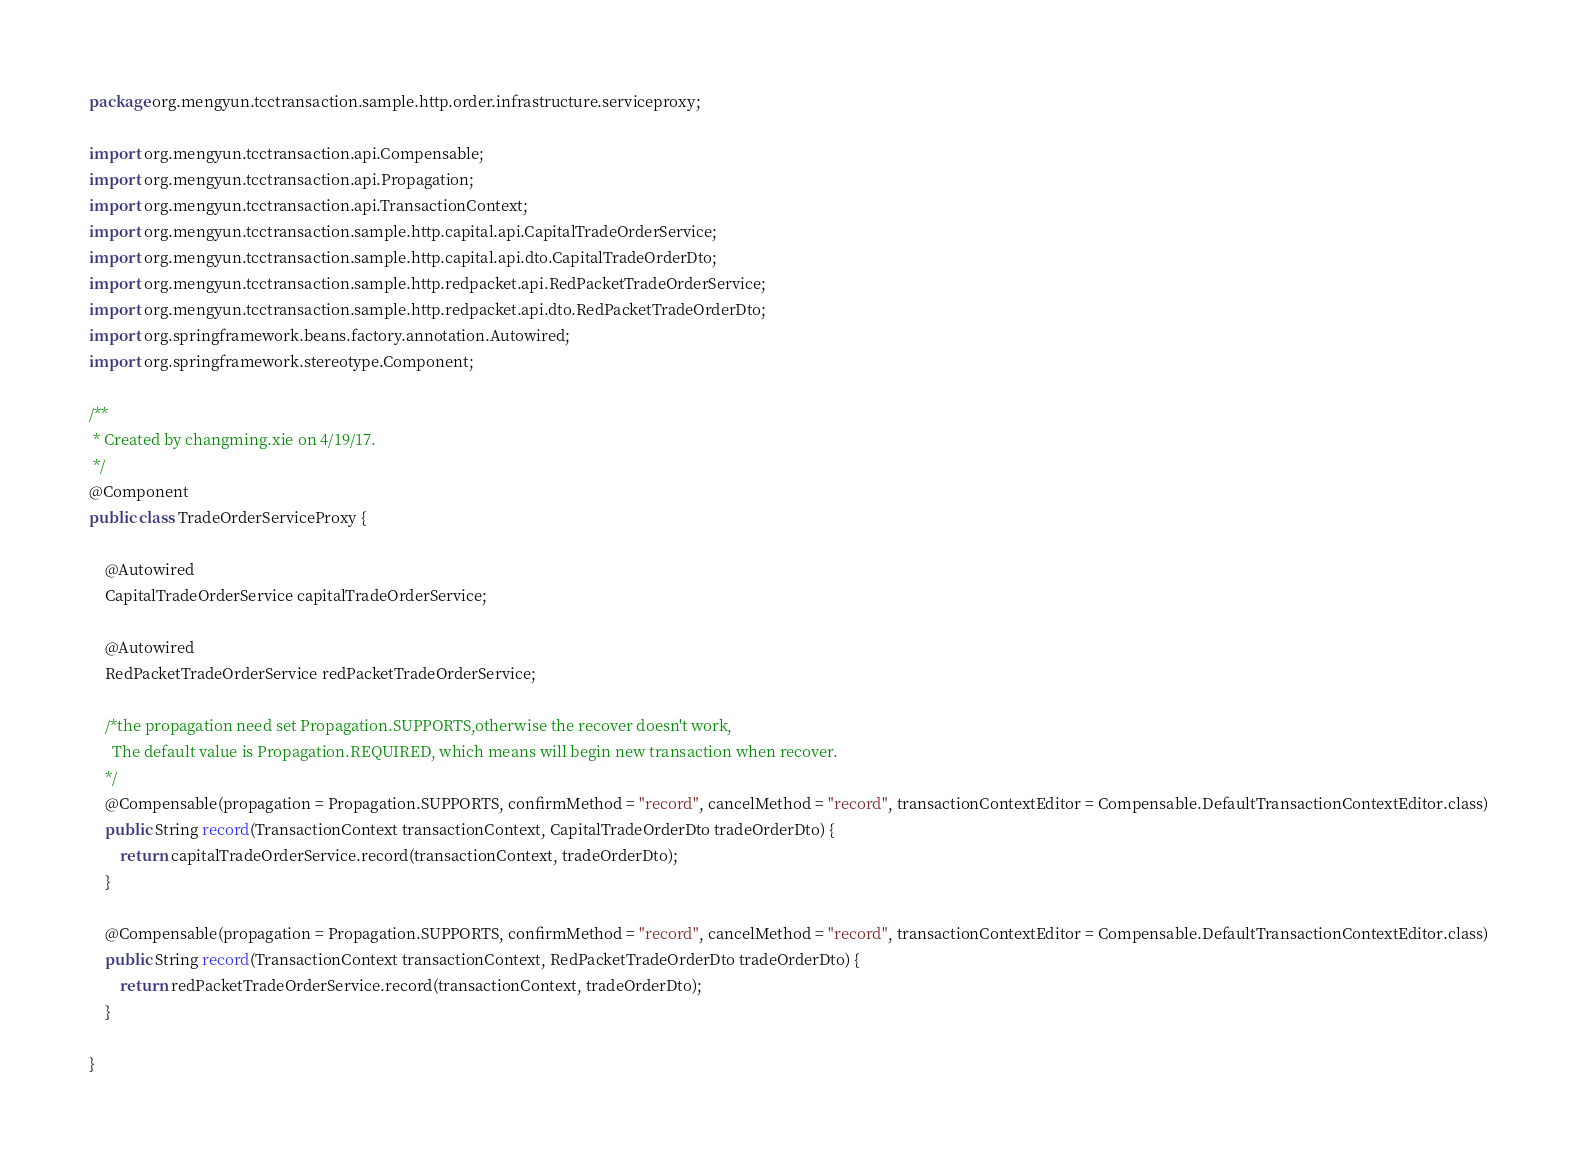Convert code to text. <code><loc_0><loc_0><loc_500><loc_500><_Java_>package org.mengyun.tcctransaction.sample.http.order.infrastructure.serviceproxy;

import org.mengyun.tcctransaction.api.Compensable;
import org.mengyun.tcctransaction.api.Propagation;
import org.mengyun.tcctransaction.api.TransactionContext;
import org.mengyun.tcctransaction.sample.http.capital.api.CapitalTradeOrderService;
import org.mengyun.tcctransaction.sample.http.capital.api.dto.CapitalTradeOrderDto;
import org.mengyun.tcctransaction.sample.http.redpacket.api.RedPacketTradeOrderService;
import org.mengyun.tcctransaction.sample.http.redpacket.api.dto.RedPacketTradeOrderDto;
import org.springframework.beans.factory.annotation.Autowired;
import org.springframework.stereotype.Component;

/**
 * Created by changming.xie on 4/19/17.
 */
@Component
public class TradeOrderServiceProxy {

    @Autowired
    CapitalTradeOrderService capitalTradeOrderService;

    @Autowired
    RedPacketTradeOrderService redPacketTradeOrderService;

    /*the propagation need set Propagation.SUPPORTS,otherwise the recover doesn't work,
      The default value is Propagation.REQUIRED, which means will begin new transaction when recover.
    */
    @Compensable(propagation = Propagation.SUPPORTS, confirmMethod = "record", cancelMethod = "record", transactionContextEditor = Compensable.DefaultTransactionContextEditor.class)
    public String record(TransactionContext transactionContext, CapitalTradeOrderDto tradeOrderDto) {
        return capitalTradeOrderService.record(transactionContext, tradeOrderDto);
    }

    @Compensable(propagation = Propagation.SUPPORTS, confirmMethod = "record", cancelMethod = "record", transactionContextEditor = Compensable.DefaultTransactionContextEditor.class)
    public String record(TransactionContext transactionContext, RedPacketTradeOrderDto tradeOrderDto) {
        return redPacketTradeOrderService.record(transactionContext, tradeOrderDto);
    }

}
</code> 